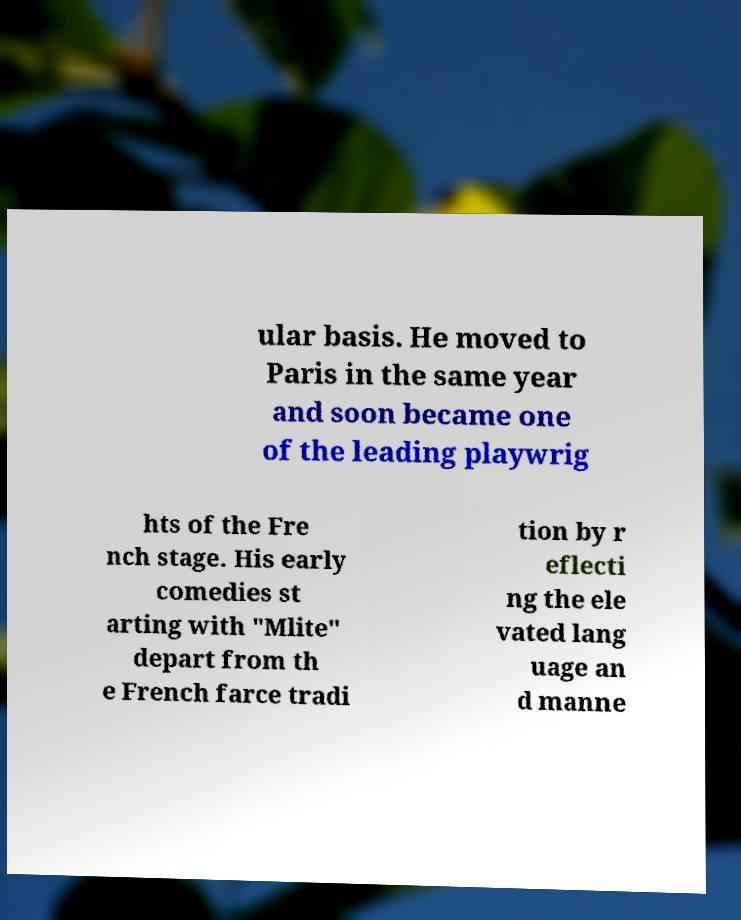For documentation purposes, I need the text within this image transcribed. Could you provide that? ular basis. He moved to Paris in the same year and soon became one of the leading playwrig hts of the Fre nch stage. His early comedies st arting with "Mlite" depart from th e French farce tradi tion by r eflecti ng the ele vated lang uage an d manne 